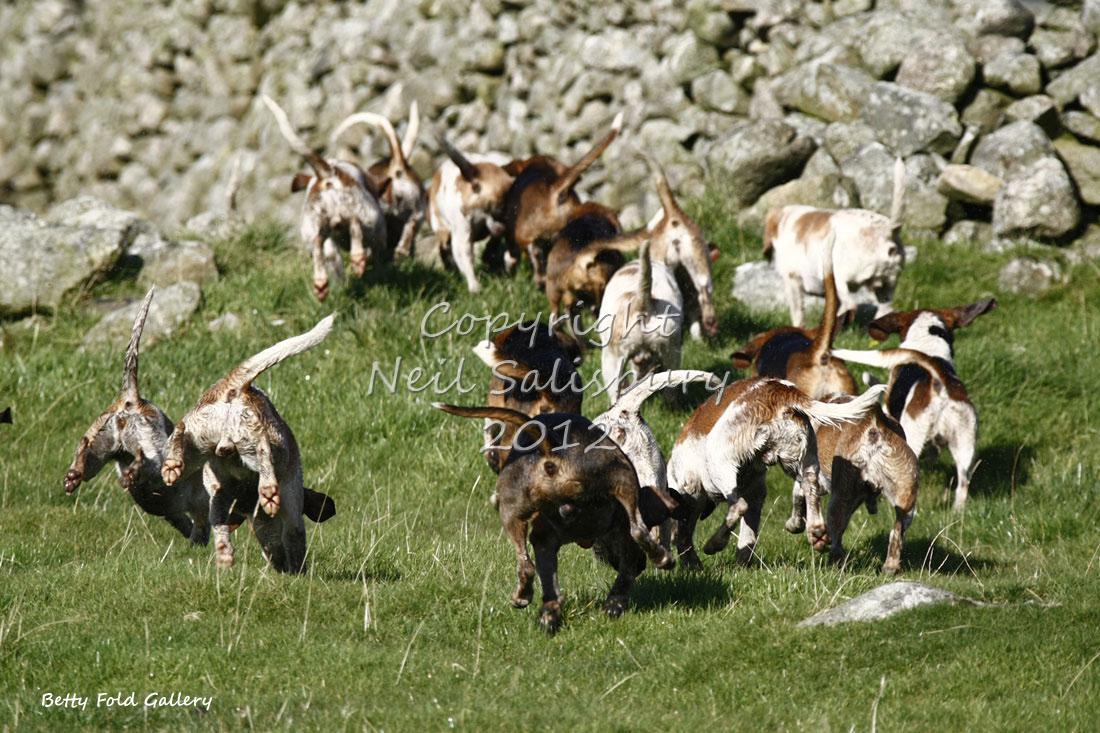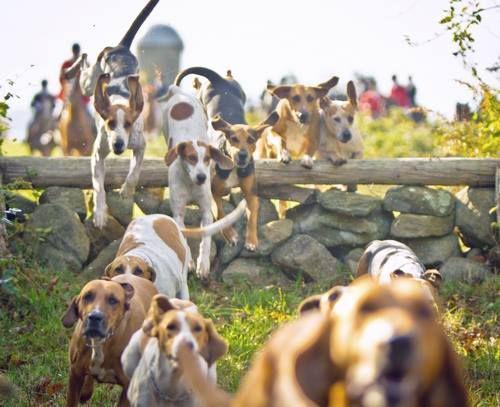The first image is the image on the left, the second image is the image on the right. For the images shown, is this caption "A man in green jacket, equestrian cap and white pants is astride a horse in the foreground of one image." true? Answer yes or no. No. The first image is the image on the left, the second image is the image on the right. Analyze the images presented: Is the assertion "At least four riders are on horses near the dogs." valid? Answer yes or no. No. 